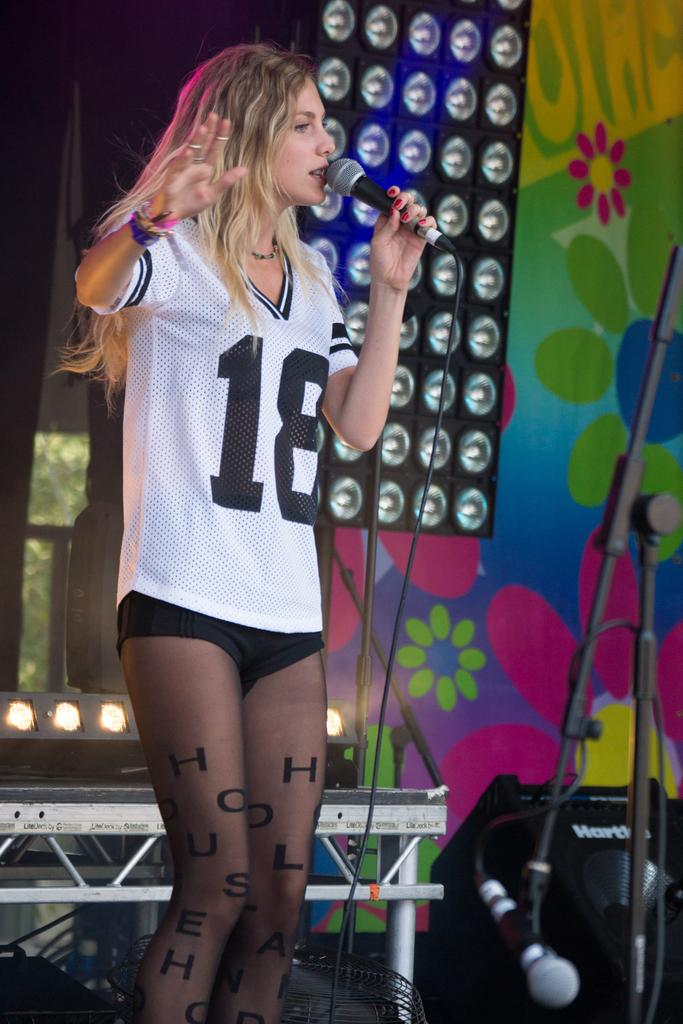<image>
Render a clear and concise summary of the photo. A girl stands on the stage with a microphone and the number 18 on her shirt and the word house on her legs 